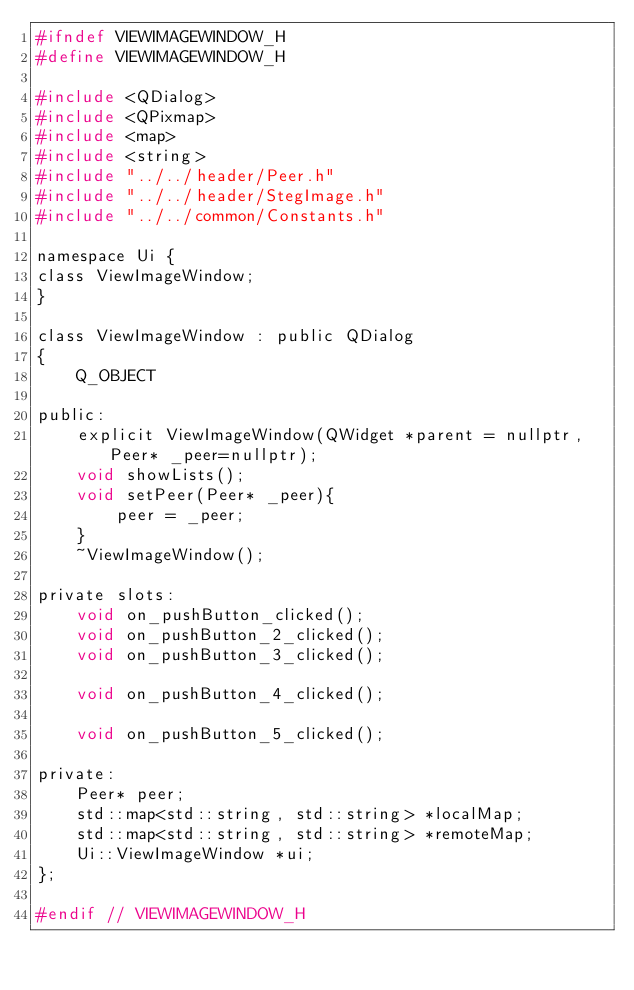<code> <loc_0><loc_0><loc_500><loc_500><_C_>#ifndef VIEWIMAGEWINDOW_H
#define VIEWIMAGEWINDOW_H

#include <QDialog>
#include <QPixmap>
#include <map>
#include <string>
#include "../../header/Peer.h"
#include "../../header/StegImage.h"
#include "../../common/Constants.h"

namespace Ui {
class ViewImageWindow;
}

class ViewImageWindow : public QDialog
{
    Q_OBJECT

public:
    explicit ViewImageWindow(QWidget *parent = nullptr,Peer* _peer=nullptr);
    void showLists();
    void setPeer(Peer* _peer){
        peer = _peer;
    }
    ~ViewImageWindow();

private slots:
    void on_pushButton_clicked();
    void on_pushButton_2_clicked();
    void on_pushButton_3_clicked();

    void on_pushButton_4_clicked();

    void on_pushButton_5_clicked();

private:
    Peer* peer;
    std::map<std::string, std::string> *localMap;
    std::map<std::string, std::string> *remoteMap;
    Ui::ViewImageWindow *ui;
};

#endif // VIEWIMAGEWINDOW_H
</code> 